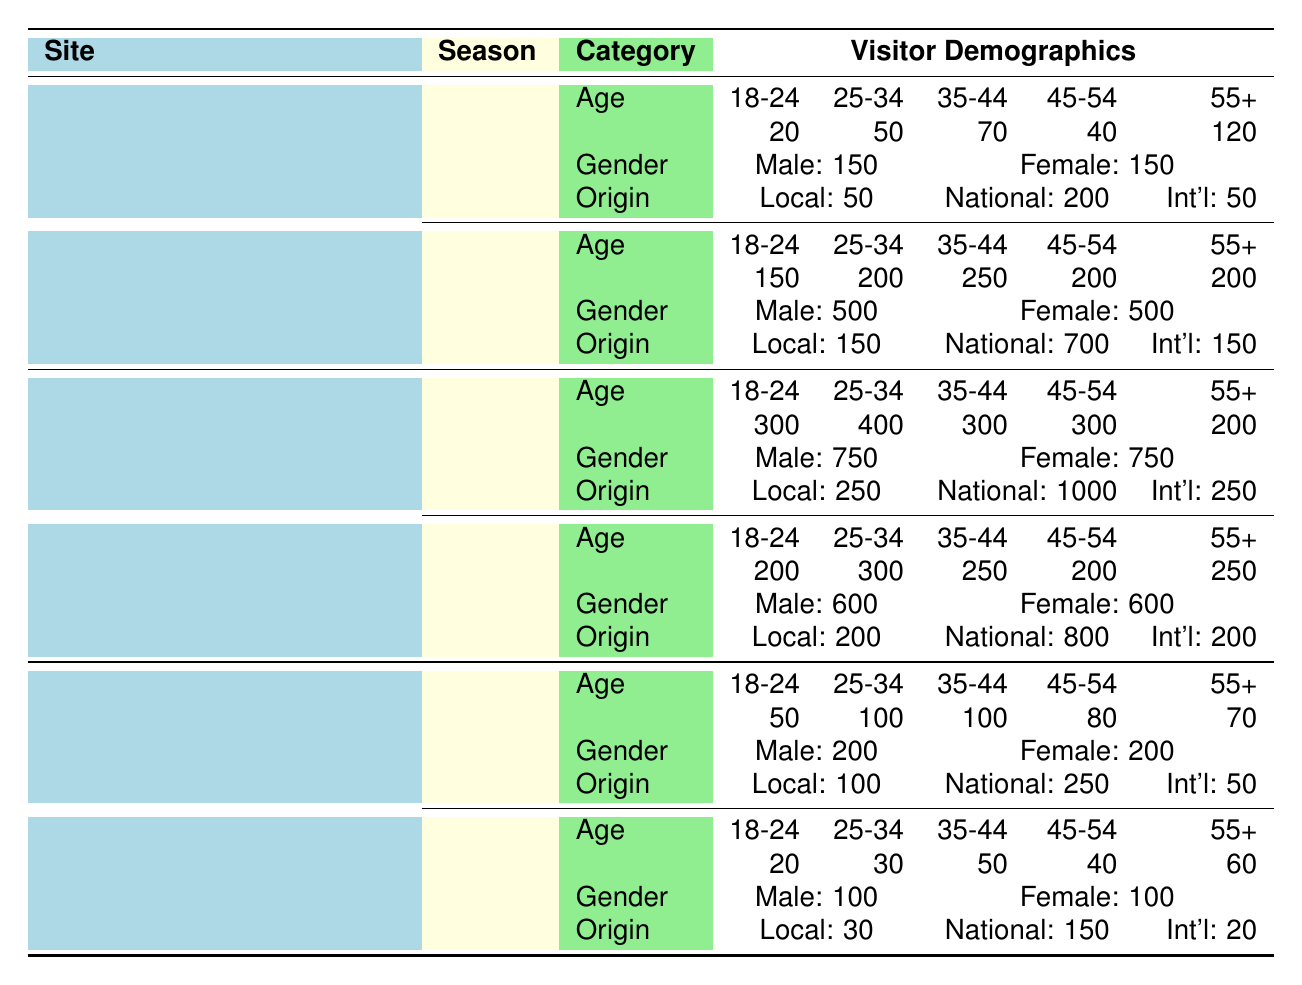What is the total number of visitors to Bodie State Historic Park in Spring? From the table under Bodie State Historic Park for the Spring season, the total number of visitors is explicitly mentioned as 1000.
Answer: 1000 What is the gender ratio for visitors to Tombstone Historic District during the Summer? The table shows that in the Summer at Tombstone Historic District, the number of male visitors is 750 and female visitors is also 750. Thus, the gender ratio is equal.
Answer: Equal How many more visitors are there in Summer at Tombstone Historic District compared to Fall? The total visitors in Summer are 1500, and in Fall, there are 1200 visitors. To find the difference, subtract Fall from Summer: 1500 - 1200 = 300.
Answer: 300 What is the average number of visitors in Winter across all three historical sites? Looking at Winter: Bodie State Historic Park has 300 visitors, Landsford Canal State Park has 200 visitors, and Tombstone Historic District has no Winter data. We take the average of the available total (300 + 200) / 2 = 250.
Answer: 250 Did Landsford Canal State Park have more local or international visitors in Spring? In Spring, Landsford Canal State Park had 100 local visitors and 50 international visitors. Since 100 > 50, there were more local visitors.
Answer: Yes What percentage of the total visitors to Tombstone Historic District in Summer were aged 25-34? In Summer, there were 1500 total visitors. The number of visitors in the 25-34 age group is 400. To find the percentage: (400 / 1500) * 100 = 26.67%.
Answer: 26.67% How many visitors in Winter at Landsford Canal State Park were in the 45-54 age group? The table shows that in Winter at Landsford Canal State Park, the number of visitors aged 45-54 is 40.
Answer: 40 Did the number of visitors aged 55+ in Spring at Bodie State Historic Park exceed the total number of visitors aged 18-24? In Spring at Bodie State Historic Park, there were 200 visitors aged 55+, while for visitors aged 18-24, there were 150. Since 200 > 150, the statement is true.
Answer: Yes 